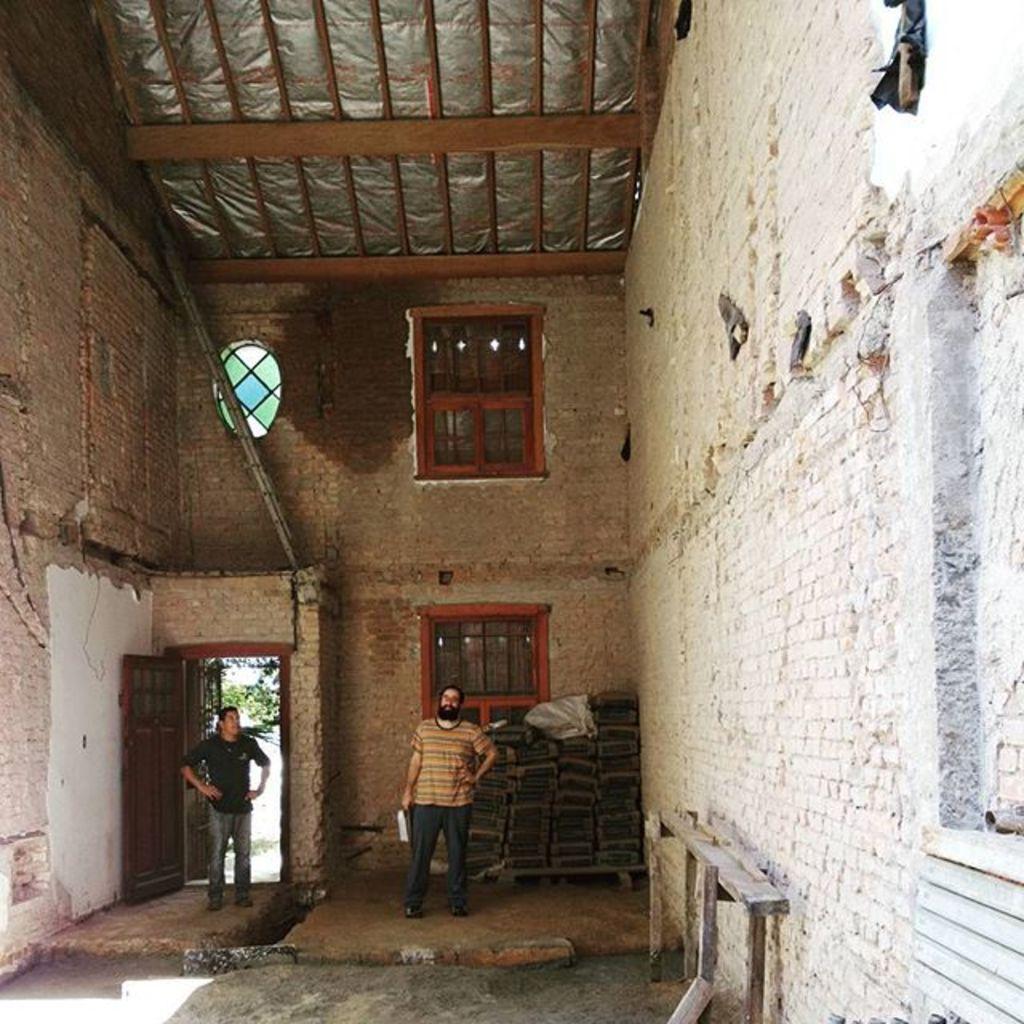Could you give a brief overview of what you see in this image? In this image there are two persons standing, behind the person there are few objects on the floor and there is a wall with bricks and windows. On the left side of the image there is an open door. At the top there is a wooden ceiling. 